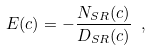<formula> <loc_0><loc_0><loc_500><loc_500>E ( c ) = - \frac { N _ { S R } ( c ) } { D _ { S R } ( c ) } \ ,</formula> 